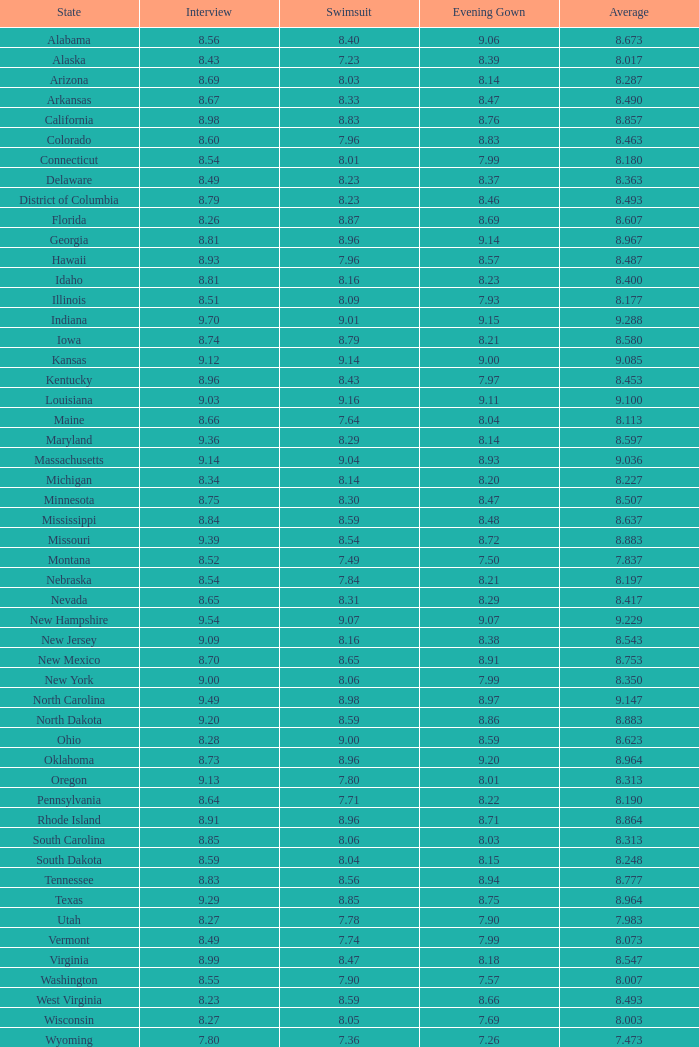453 with conversation under 1.0. 